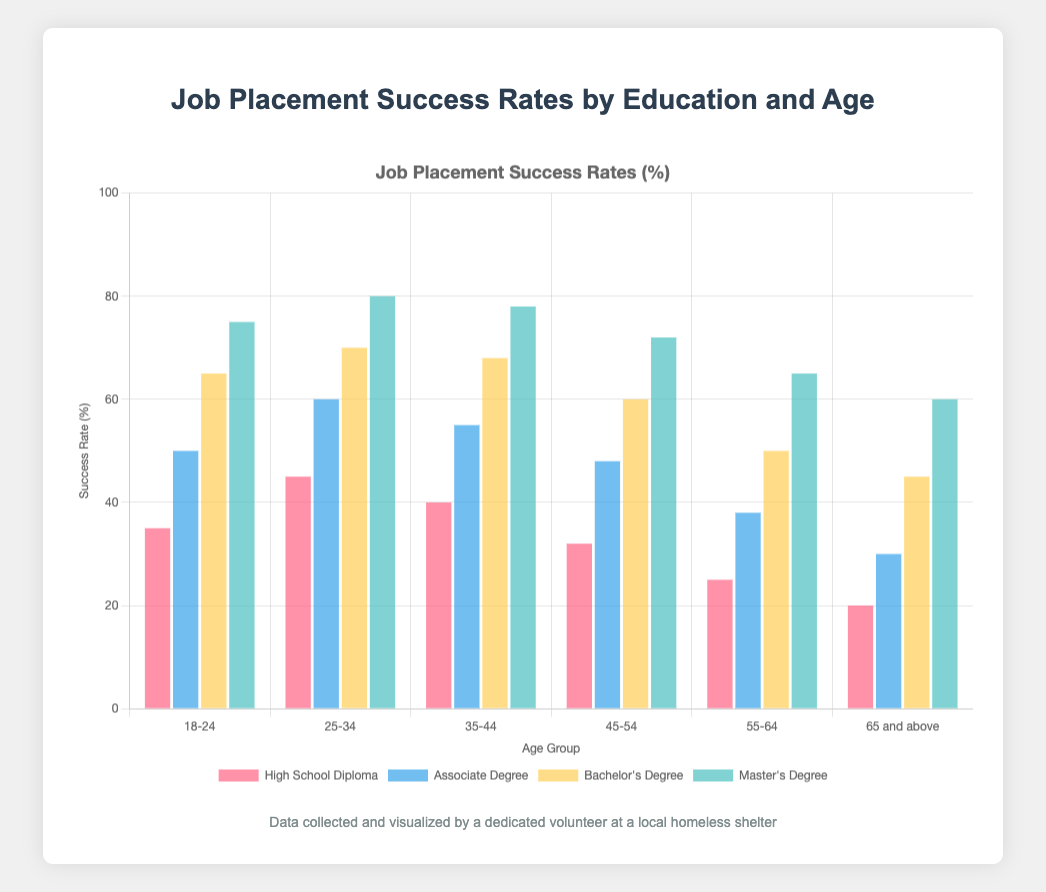Which age group has the highest job placement success rate for individuals with a Bachelor's Degree? Look at the bars in the Bachelor's Degree section across all age groups. The 25-34 age group has the tallest bar.
Answer: 25-34 What is the difference in job placement success rates between individuals with a Master's Degree and a High School Diploma within the 45-54 age group? For the 45-54 age group, the Master's Degree success rate is 72%, and the High School Diploma rate is 32%. The difference is 72 - 32.
Answer: 40% Within the 18-24 age group, by how many percentage points does the success rate for those with an Associate Degree exceed those with a High School Diploma? For the 18-24 age group, the success rate for Associate Degree is 50%, and for High School Diploma, it is 35%. The difference is 50 - 35.
Answer: 15 percentage points Which educational attainment shows the highest placement success rate for the 55-64 age group? Examine the bars for the 55-64 age group across all educational categories. The Master's Degree bar is the highest.
Answer: Master's Degree How does the job placement success rate for individuals with an Associate Degree in the 35-44 age group compare with those in the 65 and above age group? Compare the bars for the Associate Degree in the 35-44 and 65+ age groups. The 35-44 age group has a success rate of 55%, while the 65+ age group has a rate of 30%.
Answer: 35-44 has a higher success rate by 25% Combine the job placement success rates of those with High School Diplomas and Associate Degrees in the 25-34 age group and determine the combined percentage. Add the success rates for High School Diploma (45%) and Associate Degree (60%) in the 25-34 age group: 45 + 60.
Answer: 105% What is the average job placement success rate for individuals with Master's Degrees across all age groups? Sum the success rates of Master's Degrees across all age groups and divide by the number of age groups. (75 + 80 + 78 + 72 + 65 + 60) / 6.
Answer: 71.7% Compare the job placement success rates of Bachelor's Degree holders in the 35-44 age group to those in the 45-54 age group. Are they higher, lower, or equal? Compare the success rates: 68% for 35-44 and 60% for 45-54.
Answer: Higher Which color bar represents individuals with an Associate Degree on the chart? Observe the colors used for different educational categories. The Associate Degree bar is blue.
Answer: Blue How does the success rate for Master's Degrees in the 18-24 age group compare to the overall highest success rate on the chart? Highest Master's Degree success rate in the 18-24 age group is 75%, while the overall highest, found in the 25-34 age group, is 80%.
Answer: 5% lower 